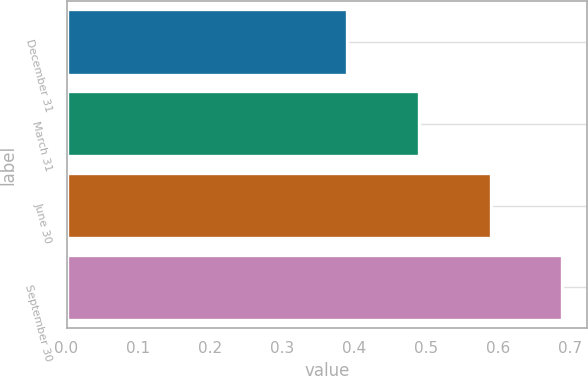Convert chart to OTSL. <chart><loc_0><loc_0><loc_500><loc_500><bar_chart><fcel>December 31<fcel>March 31<fcel>June 30<fcel>September 30<nl><fcel>0.39<fcel>0.49<fcel>0.59<fcel>0.69<nl></chart> 